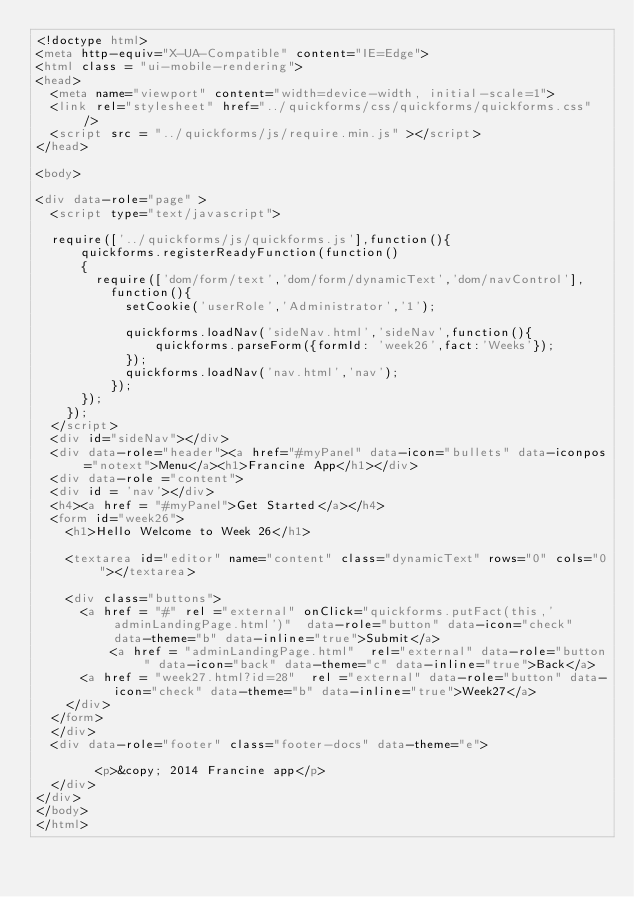<code> <loc_0><loc_0><loc_500><loc_500><_HTML_><!doctype html>
<meta http-equiv="X-UA-Compatible" content="IE=Edge">
<html class = "ui-mobile-rendering">
<head>
	<meta name="viewport" content="width=device-width, initial-scale=1">	
	<link rel="stylesheet" href="../quickforms/css/quickforms/quickforms.css" />
	<script src = "../quickforms/js/require.min.js" ></script>
</head>

<body>

<div data-role="page" >
	<script type="text/javascript">
	
	require(['../quickforms/js/quickforms.js'],function(){
			quickforms.registerReadyFunction(function()
			{
				require(['dom/form/text','dom/form/dynamicText','dom/navControl'],
					function(){
						setCookie('userRole','Administrator','1');
						
						quickforms.loadNav('sideNav.html','sideNav',function(){
								quickforms.parseForm({formId: 'week26',fact:'Weeks'});
						});
						quickforms.loadNav('nav.html','nav');
					});
			});
		});
	</script>
	<div id="sideNav"></div>
	<div data-role="header"><a href="#myPanel" data-icon="bullets" data-iconpos="notext">Menu</a><h1>Francine App</h1></div>
	<div data-role ="content">
	<div id = 'nav'></div>	
	<h4><a href = "#myPanel">Get Started</a></h4>
	<form id="week26">
		<h1>Hello Welcome to Week 26</h1>
		
		<textarea id="editor" name="content" class="dynamicText" rows="0" cols="0"></textarea>
				
		<div class="buttons">
			<a href = "#" rel ="external" onClick="quickforms.putFact(this,'adminLandingPage.html')"  data-role="button" data-icon="check" data-theme="b" data-inline="true">Submit</a>
        	<a href = "adminLandingPage.html"  rel="external" data-role="button" data-icon="back" data-theme="c" data-inline="true">Back</a>
			<a href = "week27.html?id=28"  rel ="external" data-role="button" data-icon="check" data-theme="b" data-inline="true">Week27</a>
		</div>
	</form>
	</div>
	<div data-role="footer" class="footer-docs" data-theme="e">
					
				<p>&copy; 2014 Francine app</p>
	</div>
</div>
</body>
</html></code> 